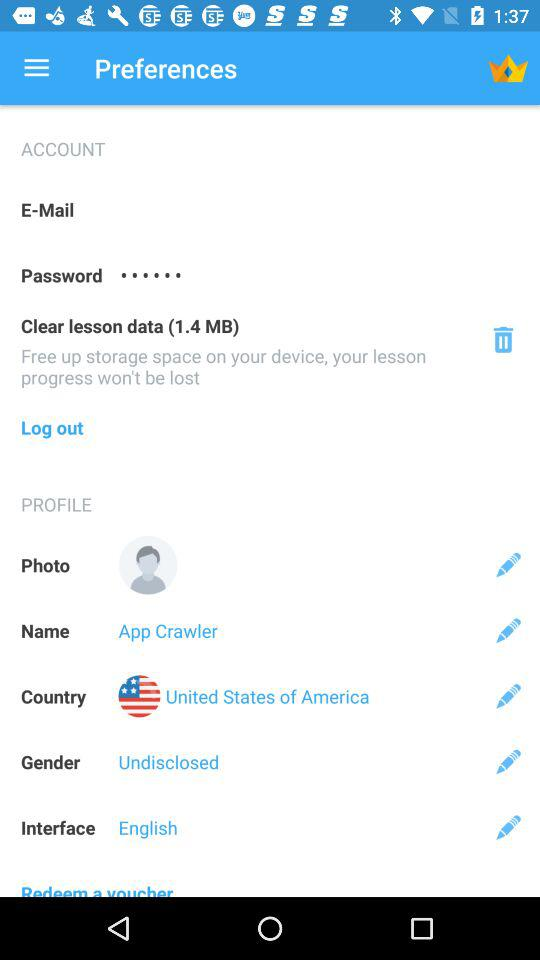Which country does the user live in? The user lives in the United States of America. 